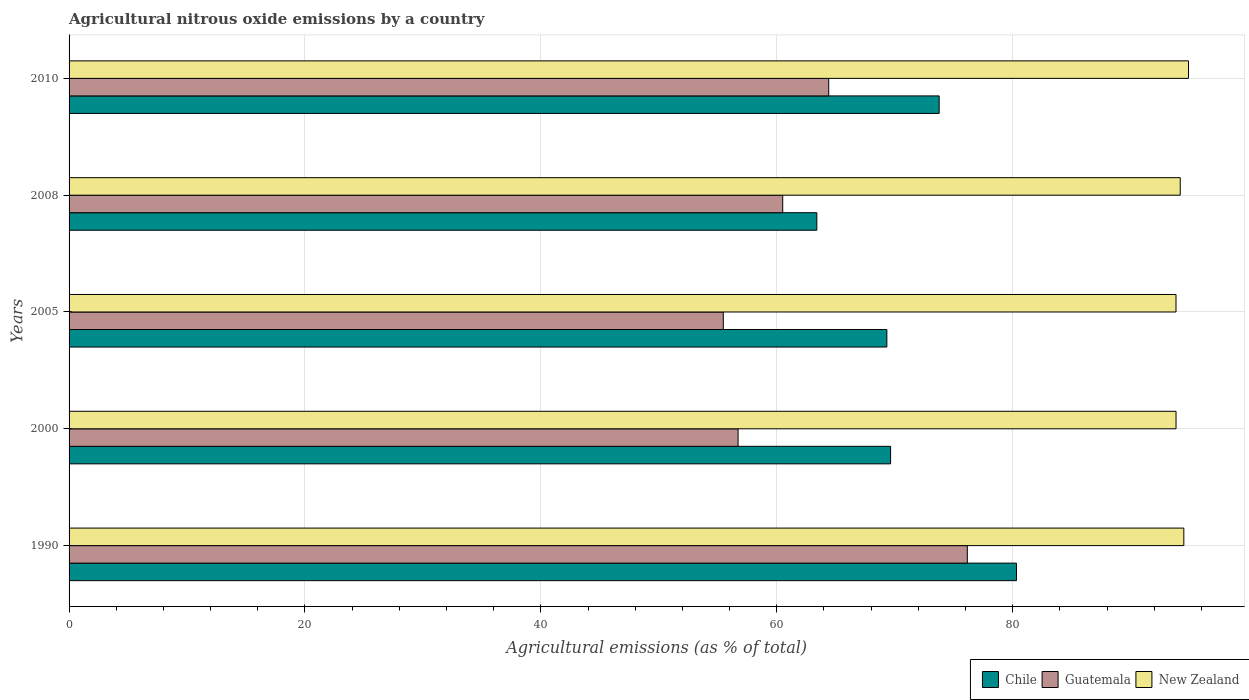Are the number of bars per tick equal to the number of legend labels?
Offer a very short reply. Yes. What is the label of the 3rd group of bars from the top?
Offer a terse response. 2005. What is the amount of agricultural nitrous oxide emitted in New Zealand in 1990?
Make the answer very short. 94.51. Across all years, what is the maximum amount of agricultural nitrous oxide emitted in Guatemala?
Your answer should be very brief. 76.15. Across all years, what is the minimum amount of agricultural nitrous oxide emitted in Chile?
Offer a very short reply. 63.39. In which year was the amount of agricultural nitrous oxide emitted in Chile maximum?
Your response must be concise. 1990. In which year was the amount of agricultural nitrous oxide emitted in Guatemala minimum?
Provide a short and direct response. 2005. What is the total amount of agricultural nitrous oxide emitted in New Zealand in the graph?
Provide a short and direct response. 471.32. What is the difference between the amount of agricultural nitrous oxide emitted in New Zealand in 2008 and that in 2010?
Make the answer very short. -0.7. What is the difference between the amount of agricultural nitrous oxide emitted in Chile in 1990 and the amount of agricultural nitrous oxide emitted in Guatemala in 2008?
Your answer should be very brief. 19.82. What is the average amount of agricultural nitrous oxide emitted in Chile per year?
Your answer should be very brief. 71.29. In the year 2008, what is the difference between the amount of agricultural nitrous oxide emitted in Chile and amount of agricultural nitrous oxide emitted in Guatemala?
Ensure brevity in your answer.  2.89. What is the ratio of the amount of agricultural nitrous oxide emitted in Chile in 2005 to that in 2008?
Your answer should be very brief. 1.09. Is the difference between the amount of agricultural nitrous oxide emitted in Chile in 2000 and 2005 greater than the difference between the amount of agricultural nitrous oxide emitted in Guatemala in 2000 and 2005?
Your answer should be compact. No. What is the difference between the highest and the second highest amount of agricultural nitrous oxide emitted in Chile?
Your answer should be very brief. 6.55. What is the difference between the highest and the lowest amount of agricultural nitrous oxide emitted in Guatemala?
Provide a succinct answer. 20.69. Is the sum of the amount of agricultural nitrous oxide emitted in Guatemala in 2008 and 2010 greater than the maximum amount of agricultural nitrous oxide emitted in New Zealand across all years?
Ensure brevity in your answer.  Yes. What does the 2nd bar from the top in 1990 represents?
Your answer should be compact. Guatemala. What does the 2nd bar from the bottom in 2000 represents?
Offer a very short reply. Guatemala. How many years are there in the graph?
Ensure brevity in your answer.  5. What is the difference between two consecutive major ticks on the X-axis?
Ensure brevity in your answer.  20. Does the graph contain grids?
Keep it short and to the point. Yes. How many legend labels are there?
Your answer should be compact. 3. What is the title of the graph?
Your answer should be compact. Agricultural nitrous oxide emissions by a country. Does "Guyana" appear as one of the legend labels in the graph?
Make the answer very short. No. What is the label or title of the X-axis?
Give a very brief answer. Agricultural emissions (as % of total). What is the Agricultural emissions (as % of total) in Chile in 1990?
Your response must be concise. 80.32. What is the Agricultural emissions (as % of total) in Guatemala in 1990?
Your answer should be compact. 76.15. What is the Agricultural emissions (as % of total) in New Zealand in 1990?
Ensure brevity in your answer.  94.51. What is the Agricultural emissions (as % of total) of Chile in 2000?
Your answer should be very brief. 69.65. What is the Agricultural emissions (as % of total) in Guatemala in 2000?
Offer a terse response. 56.72. What is the Agricultural emissions (as % of total) of New Zealand in 2000?
Your answer should be compact. 93.85. What is the Agricultural emissions (as % of total) in Chile in 2005?
Your answer should be compact. 69.33. What is the Agricultural emissions (as % of total) in Guatemala in 2005?
Keep it short and to the point. 55.47. What is the Agricultural emissions (as % of total) in New Zealand in 2005?
Make the answer very short. 93.85. What is the Agricultural emissions (as % of total) of Chile in 2008?
Make the answer very short. 63.39. What is the Agricultural emissions (as % of total) in Guatemala in 2008?
Your answer should be compact. 60.5. What is the Agricultural emissions (as % of total) in New Zealand in 2008?
Offer a terse response. 94.21. What is the Agricultural emissions (as % of total) in Chile in 2010?
Provide a short and direct response. 73.77. What is the Agricultural emissions (as % of total) in Guatemala in 2010?
Keep it short and to the point. 64.4. What is the Agricultural emissions (as % of total) in New Zealand in 2010?
Your answer should be very brief. 94.91. Across all years, what is the maximum Agricultural emissions (as % of total) in Chile?
Offer a very short reply. 80.32. Across all years, what is the maximum Agricultural emissions (as % of total) in Guatemala?
Ensure brevity in your answer.  76.15. Across all years, what is the maximum Agricultural emissions (as % of total) of New Zealand?
Give a very brief answer. 94.91. Across all years, what is the minimum Agricultural emissions (as % of total) in Chile?
Ensure brevity in your answer.  63.39. Across all years, what is the minimum Agricultural emissions (as % of total) in Guatemala?
Offer a very short reply. 55.47. Across all years, what is the minimum Agricultural emissions (as % of total) of New Zealand?
Your response must be concise. 93.85. What is the total Agricultural emissions (as % of total) of Chile in the graph?
Your answer should be compact. 356.46. What is the total Agricultural emissions (as % of total) in Guatemala in the graph?
Make the answer very short. 313.24. What is the total Agricultural emissions (as % of total) of New Zealand in the graph?
Keep it short and to the point. 471.32. What is the difference between the Agricultural emissions (as % of total) in Chile in 1990 and that in 2000?
Your answer should be compact. 10.67. What is the difference between the Agricultural emissions (as % of total) of Guatemala in 1990 and that in 2000?
Give a very brief answer. 19.43. What is the difference between the Agricultural emissions (as % of total) of New Zealand in 1990 and that in 2000?
Keep it short and to the point. 0.66. What is the difference between the Agricultural emissions (as % of total) in Chile in 1990 and that in 2005?
Your answer should be compact. 10.99. What is the difference between the Agricultural emissions (as % of total) of Guatemala in 1990 and that in 2005?
Your answer should be compact. 20.69. What is the difference between the Agricultural emissions (as % of total) in New Zealand in 1990 and that in 2005?
Your answer should be compact. 0.66. What is the difference between the Agricultural emissions (as % of total) of Chile in 1990 and that in 2008?
Your answer should be compact. 16.93. What is the difference between the Agricultural emissions (as % of total) of Guatemala in 1990 and that in 2008?
Ensure brevity in your answer.  15.65. What is the difference between the Agricultural emissions (as % of total) of New Zealand in 1990 and that in 2008?
Keep it short and to the point. 0.3. What is the difference between the Agricultural emissions (as % of total) in Chile in 1990 and that in 2010?
Make the answer very short. 6.55. What is the difference between the Agricultural emissions (as % of total) of Guatemala in 1990 and that in 2010?
Give a very brief answer. 11.75. What is the difference between the Agricultural emissions (as % of total) of New Zealand in 1990 and that in 2010?
Ensure brevity in your answer.  -0.4. What is the difference between the Agricultural emissions (as % of total) of Chile in 2000 and that in 2005?
Offer a very short reply. 0.32. What is the difference between the Agricultural emissions (as % of total) in Guatemala in 2000 and that in 2005?
Provide a short and direct response. 1.25. What is the difference between the Agricultural emissions (as % of total) in New Zealand in 2000 and that in 2005?
Provide a succinct answer. 0. What is the difference between the Agricultural emissions (as % of total) of Chile in 2000 and that in 2008?
Your answer should be very brief. 6.25. What is the difference between the Agricultural emissions (as % of total) in Guatemala in 2000 and that in 2008?
Offer a terse response. -3.78. What is the difference between the Agricultural emissions (as % of total) in New Zealand in 2000 and that in 2008?
Your response must be concise. -0.36. What is the difference between the Agricultural emissions (as % of total) of Chile in 2000 and that in 2010?
Your answer should be compact. -4.12. What is the difference between the Agricultural emissions (as % of total) of Guatemala in 2000 and that in 2010?
Provide a short and direct response. -7.68. What is the difference between the Agricultural emissions (as % of total) in New Zealand in 2000 and that in 2010?
Your answer should be very brief. -1.06. What is the difference between the Agricultural emissions (as % of total) in Chile in 2005 and that in 2008?
Provide a succinct answer. 5.94. What is the difference between the Agricultural emissions (as % of total) of Guatemala in 2005 and that in 2008?
Give a very brief answer. -5.04. What is the difference between the Agricultural emissions (as % of total) of New Zealand in 2005 and that in 2008?
Provide a succinct answer. -0.36. What is the difference between the Agricultural emissions (as % of total) of Chile in 2005 and that in 2010?
Your answer should be compact. -4.44. What is the difference between the Agricultural emissions (as % of total) of Guatemala in 2005 and that in 2010?
Ensure brevity in your answer.  -8.94. What is the difference between the Agricultural emissions (as % of total) in New Zealand in 2005 and that in 2010?
Your answer should be compact. -1.06. What is the difference between the Agricultural emissions (as % of total) of Chile in 2008 and that in 2010?
Your answer should be very brief. -10.37. What is the difference between the Agricultural emissions (as % of total) of Guatemala in 2008 and that in 2010?
Ensure brevity in your answer.  -3.9. What is the difference between the Agricultural emissions (as % of total) of New Zealand in 2008 and that in 2010?
Provide a short and direct response. -0.7. What is the difference between the Agricultural emissions (as % of total) of Chile in 1990 and the Agricultural emissions (as % of total) of Guatemala in 2000?
Give a very brief answer. 23.6. What is the difference between the Agricultural emissions (as % of total) in Chile in 1990 and the Agricultural emissions (as % of total) in New Zealand in 2000?
Your response must be concise. -13.53. What is the difference between the Agricultural emissions (as % of total) of Guatemala in 1990 and the Agricultural emissions (as % of total) of New Zealand in 2000?
Make the answer very short. -17.69. What is the difference between the Agricultural emissions (as % of total) of Chile in 1990 and the Agricultural emissions (as % of total) of Guatemala in 2005?
Ensure brevity in your answer.  24.86. What is the difference between the Agricultural emissions (as % of total) of Chile in 1990 and the Agricultural emissions (as % of total) of New Zealand in 2005?
Ensure brevity in your answer.  -13.52. What is the difference between the Agricultural emissions (as % of total) of Guatemala in 1990 and the Agricultural emissions (as % of total) of New Zealand in 2005?
Your answer should be compact. -17.69. What is the difference between the Agricultural emissions (as % of total) of Chile in 1990 and the Agricultural emissions (as % of total) of Guatemala in 2008?
Offer a very short reply. 19.82. What is the difference between the Agricultural emissions (as % of total) of Chile in 1990 and the Agricultural emissions (as % of total) of New Zealand in 2008?
Ensure brevity in your answer.  -13.88. What is the difference between the Agricultural emissions (as % of total) of Guatemala in 1990 and the Agricultural emissions (as % of total) of New Zealand in 2008?
Ensure brevity in your answer.  -18.05. What is the difference between the Agricultural emissions (as % of total) of Chile in 1990 and the Agricultural emissions (as % of total) of Guatemala in 2010?
Provide a succinct answer. 15.92. What is the difference between the Agricultural emissions (as % of total) of Chile in 1990 and the Agricultural emissions (as % of total) of New Zealand in 2010?
Keep it short and to the point. -14.59. What is the difference between the Agricultural emissions (as % of total) of Guatemala in 1990 and the Agricultural emissions (as % of total) of New Zealand in 2010?
Keep it short and to the point. -18.75. What is the difference between the Agricultural emissions (as % of total) in Chile in 2000 and the Agricultural emissions (as % of total) in Guatemala in 2005?
Ensure brevity in your answer.  14.18. What is the difference between the Agricultural emissions (as % of total) of Chile in 2000 and the Agricultural emissions (as % of total) of New Zealand in 2005?
Keep it short and to the point. -24.2. What is the difference between the Agricultural emissions (as % of total) of Guatemala in 2000 and the Agricultural emissions (as % of total) of New Zealand in 2005?
Your response must be concise. -37.13. What is the difference between the Agricultural emissions (as % of total) of Chile in 2000 and the Agricultural emissions (as % of total) of Guatemala in 2008?
Provide a short and direct response. 9.14. What is the difference between the Agricultural emissions (as % of total) in Chile in 2000 and the Agricultural emissions (as % of total) in New Zealand in 2008?
Keep it short and to the point. -24.56. What is the difference between the Agricultural emissions (as % of total) in Guatemala in 2000 and the Agricultural emissions (as % of total) in New Zealand in 2008?
Provide a succinct answer. -37.49. What is the difference between the Agricultural emissions (as % of total) in Chile in 2000 and the Agricultural emissions (as % of total) in Guatemala in 2010?
Make the answer very short. 5.25. What is the difference between the Agricultural emissions (as % of total) in Chile in 2000 and the Agricultural emissions (as % of total) in New Zealand in 2010?
Your response must be concise. -25.26. What is the difference between the Agricultural emissions (as % of total) in Guatemala in 2000 and the Agricultural emissions (as % of total) in New Zealand in 2010?
Offer a very short reply. -38.19. What is the difference between the Agricultural emissions (as % of total) in Chile in 2005 and the Agricultural emissions (as % of total) in Guatemala in 2008?
Your answer should be compact. 8.83. What is the difference between the Agricultural emissions (as % of total) of Chile in 2005 and the Agricultural emissions (as % of total) of New Zealand in 2008?
Your response must be concise. -24.87. What is the difference between the Agricultural emissions (as % of total) of Guatemala in 2005 and the Agricultural emissions (as % of total) of New Zealand in 2008?
Offer a terse response. -38.74. What is the difference between the Agricultural emissions (as % of total) of Chile in 2005 and the Agricultural emissions (as % of total) of Guatemala in 2010?
Give a very brief answer. 4.93. What is the difference between the Agricultural emissions (as % of total) in Chile in 2005 and the Agricultural emissions (as % of total) in New Zealand in 2010?
Keep it short and to the point. -25.58. What is the difference between the Agricultural emissions (as % of total) in Guatemala in 2005 and the Agricultural emissions (as % of total) in New Zealand in 2010?
Offer a very short reply. -39.44. What is the difference between the Agricultural emissions (as % of total) in Chile in 2008 and the Agricultural emissions (as % of total) in Guatemala in 2010?
Keep it short and to the point. -1.01. What is the difference between the Agricultural emissions (as % of total) in Chile in 2008 and the Agricultural emissions (as % of total) in New Zealand in 2010?
Ensure brevity in your answer.  -31.51. What is the difference between the Agricultural emissions (as % of total) in Guatemala in 2008 and the Agricultural emissions (as % of total) in New Zealand in 2010?
Your response must be concise. -34.4. What is the average Agricultural emissions (as % of total) in Chile per year?
Keep it short and to the point. 71.29. What is the average Agricultural emissions (as % of total) of Guatemala per year?
Give a very brief answer. 62.65. What is the average Agricultural emissions (as % of total) in New Zealand per year?
Give a very brief answer. 94.26. In the year 1990, what is the difference between the Agricultural emissions (as % of total) in Chile and Agricultural emissions (as % of total) in Guatemala?
Your answer should be compact. 4.17. In the year 1990, what is the difference between the Agricultural emissions (as % of total) in Chile and Agricultural emissions (as % of total) in New Zealand?
Give a very brief answer. -14.19. In the year 1990, what is the difference between the Agricultural emissions (as % of total) in Guatemala and Agricultural emissions (as % of total) in New Zealand?
Your answer should be very brief. -18.36. In the year 2000, what is the difference between the Agricultural emissions (as % of total) of Chile and Agricultural emissions (as % of total) of Guatemala?
Offer a terse response. 12.93. In the year 2000, what is the difference between the Agricultural emissions (as % of total) in Chile and Agricultural emissions (as % of total) in New Zealand?
Make the answer very short. -24.2. In the year 2000, what is the difference between the Agricultural emissions (as % of total) in Guatemala and Agricultural emissions (as % of total) in New Zealand?
Your response must be concise. -37.13. In the year 2005, what is the difference between the Agricultural emissions (as % of total) in Chile and Agricultural emissions (as % of total) in Guatemala?
Provide a succinct answer. 13.87. In the year 2005, what is the difference between the Agricultural emissions (as % of total) of Chile and Agricultural emissions (as % of total) of New Zealand?
Keep it short and to the point. -24.51. In the year 2005, what is the difference between the Agricultural emissions (as % of total) of Guatemala and Agricultural emissions (as % of total) of New Zealand?
Offer a terse response. -38.38. In the year 2008, what is the difference between the Agricultural emissions (as % of total) in Chile and Agricultural emissions (as % of total) in Guatemala?
Your answer should be compact. 2.89. In the year 2008, what is the difference between the Agricultural emissions (as % of total) in Chile and Agricultural emissions (as % of total) in New Zealand?
Your response must be concise. -30.81. In the year 2008, what is the difference between the Agricultural emissions (as % of total) in Guatemala and Agricultural emissions (as % of total) in New Zealand?
Provide a succinct answer. -33.7. In the year 2010, what is the difference between the Agricultural emissions (as % of total) of Chile and Agricultural emissions (as % of total) of Guatemala?
Your answer should be compact. 9.36. In the year 2010, what is the difference between the Agricultural emissions (as % of total) in Chile and Agricultural emissions (as % of total) in New Zealand?
Your answer should be very brief. -21.14. In the year 2010, what is the difference between the Agricultural emissions (as % of total) in Guatemala and Agricultural emissions (as % of total) in New Zealand?
Ensure brevity in your answer.  -30.5. What is the ratio of the Agricultural emissions (as % of total) of Chile in 1990 to that in 2000?
Your response must be concise. 1.15. What is the ratio of the Agricultural emissions (as % of total) of Guatemala in 1990 to that in 2000?
Provide a short and direct response. 1.34. What is the ratio of the Agricultural emissions (as % of total) of New Zealand in 1990 to that in 2000?
Offer a very short reply. 1.01. What is the ratio of the Agricultural emissions (as % of total) in Chile in 1990 to that in 2005?
Your response must be concise. 1.16. What is the ratio of the Agricultural emissions (as % of total) in Guatemala in 1990 to that in 2005?
Give a very brief answer. 1.37. What is the ratio of the Agricultural emissions (as % of total) of New Zealand in 1990 to that in 2005?
Provide a short and direct response. 1.01. What is the ratio of the Agricultural emissions (as % of total) of Chile in 1990 to that in 2008?
Keep it short and to the point. 1.27. What is the ratio of the Agricultural emissions (as % of total) of Guatemala in 1990 to that in 2008?
Your response must be concise. 1.26. What is the ratio of the Agricultural emissions (as % of total) in Chile in 1990 to that in 2010?
Make the answer very short. 1.09. What is the ratio of the Agricultural emissions (as % of total) of Guatemala in 1990 to that in 2010?
Ensure brevity in your answer.  1.18. What is the ratio of the Agricultural emissions (as % of total) in Guatemala in 2000 to that in 2005?
Your answer should be compact. 1.02. What is the ratio of the Agricultural emissions (as % of total) in New Zealand in 2000 to that in 2005?
Ensure brevity in your answer.  1. What is the ratio of the Agricultural emissions (as % of total) of Chile in 2000 to that in 2008?
Provide a short and direct response. 1.1. What is the ratio of the Agricultural emissions (as % of total) in New Zealand in 2000 to that in 2008?
Provide a succinct answer. 1. What is the ratio of the Agricultural emissions (as % of total) in Chile in 2000 to that in 2010?
Give a very brief answer. 0.94. What is the ratio of the Agricultural emissions (as % of total) in Guatemala in 2000 to that in 2010?
Provide a short and direct response. 0.88. What is the ratio of the Agricultural emissions (as % of total) in Chile in 2005 to that in 2008?
Ensure brevity in your answer.  1.09. What is the ratio of the Agricultural emissions (as % of total) in Guatemala in 2005 to that in 2008?
Ensure brevity in your answer.  0.92. What is the ratio of the Agricultural emissions (as % of total) in Chile in 2005 to that in 2010?
Your answer should be very brief. 0.94. What is the ratio of the Agricultural emissions (as % of total) of Guatemala in 2005 to that in 2010?
Make the answer very short. 0.86. What is the ratio of the Agricultural emissions (as % of total) of New Zealand in 2005 to that in 2010?
Your answer should be compact. 0.99. What is the ratio of the Agricultural emissions (as % of total) of Chile in 2008 to that in 2010?
Offer a terse response. 0.86. What is the ratio of the Agricultural emissions (as % of total) of Guatemala in 2008 to that in 2010?
Give a very brief answer. 0.94. What is the difference between the highest and the second highest Agricultural emissions (as % of total) of Chile?
Ensure brevity in your answer.  6.55. What is the difference between the highest and the second highest Agricultural emissions (as % of total) in Guatemala?
Give a very brief answer. 11.75. What is the difference between the highest and the second highest Agricultural emissions (as % of total) of New Zealand?
Keep it short and to the point. 0.4. What is the difference between the highest and the lowest Agricultural emissions (as % of total) of Chile?
Make the answer very short. 16.93. What is the difference between the highest and the lowest Agricultural emissions (as % of total) in Guatemala?
Provide a short and direct response. 20.69. What is the difference between the highest and the lowest Agricultural emissions (as % of total) of New Zealand?
Provide a succinct answer. 1.06. 